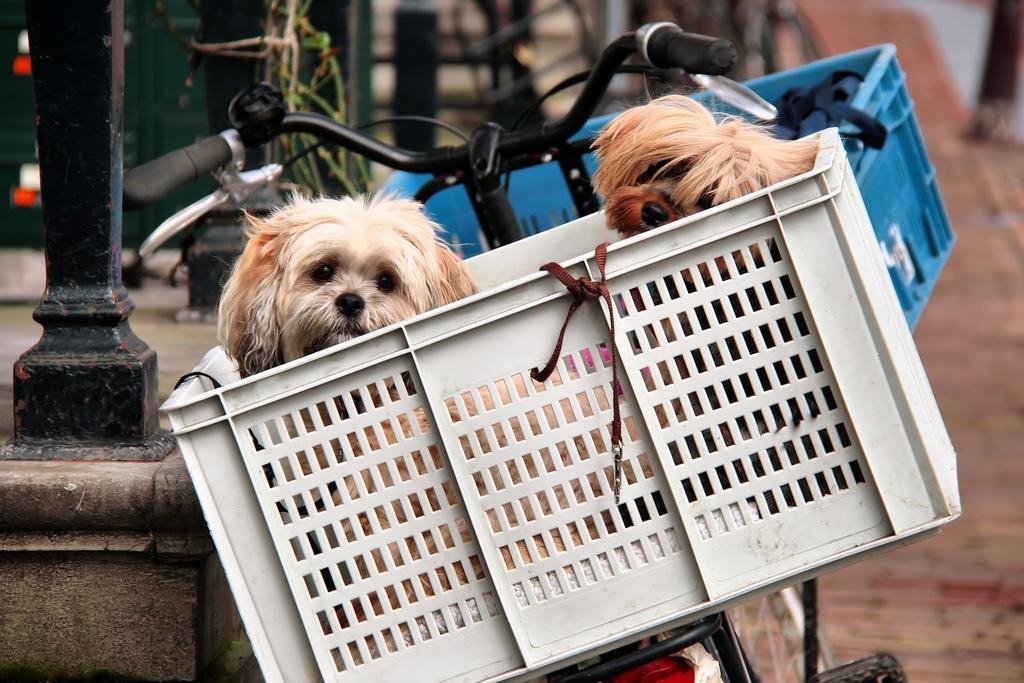How would you summarize this image in a sentence or two? In the middle of the image we can see a bicycle, on the bicycle we can baskets. In the baskets there are two dogs. Behind the bicycles there are some poles and background of the image is blur. 